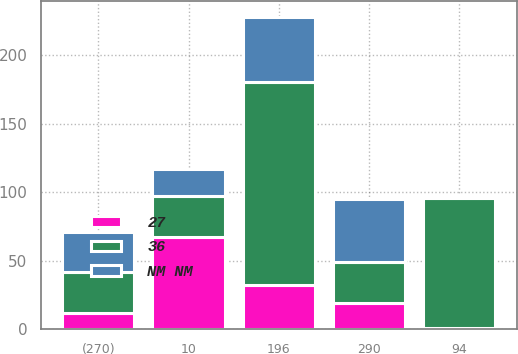Convert chart to OTSL. <chart><loc_0><loc_0><loc_500><loc_500><stacked_bar_chart><ecel><fcel>10<fcel>94<fcel>196<fcel>290<fcel>(270)<nl><fcel>36<fcel>30<fcel>95<fcel>148<fcel>30<fcel>30<nl><fcel>NM NM<fcel>20<fcel>1<fcel>48<fcel>46<fcel>29<nl><fcel>27<fcel>67<fcel>1<fcel>32<fcel>19<fcel>12<nl></chart> 